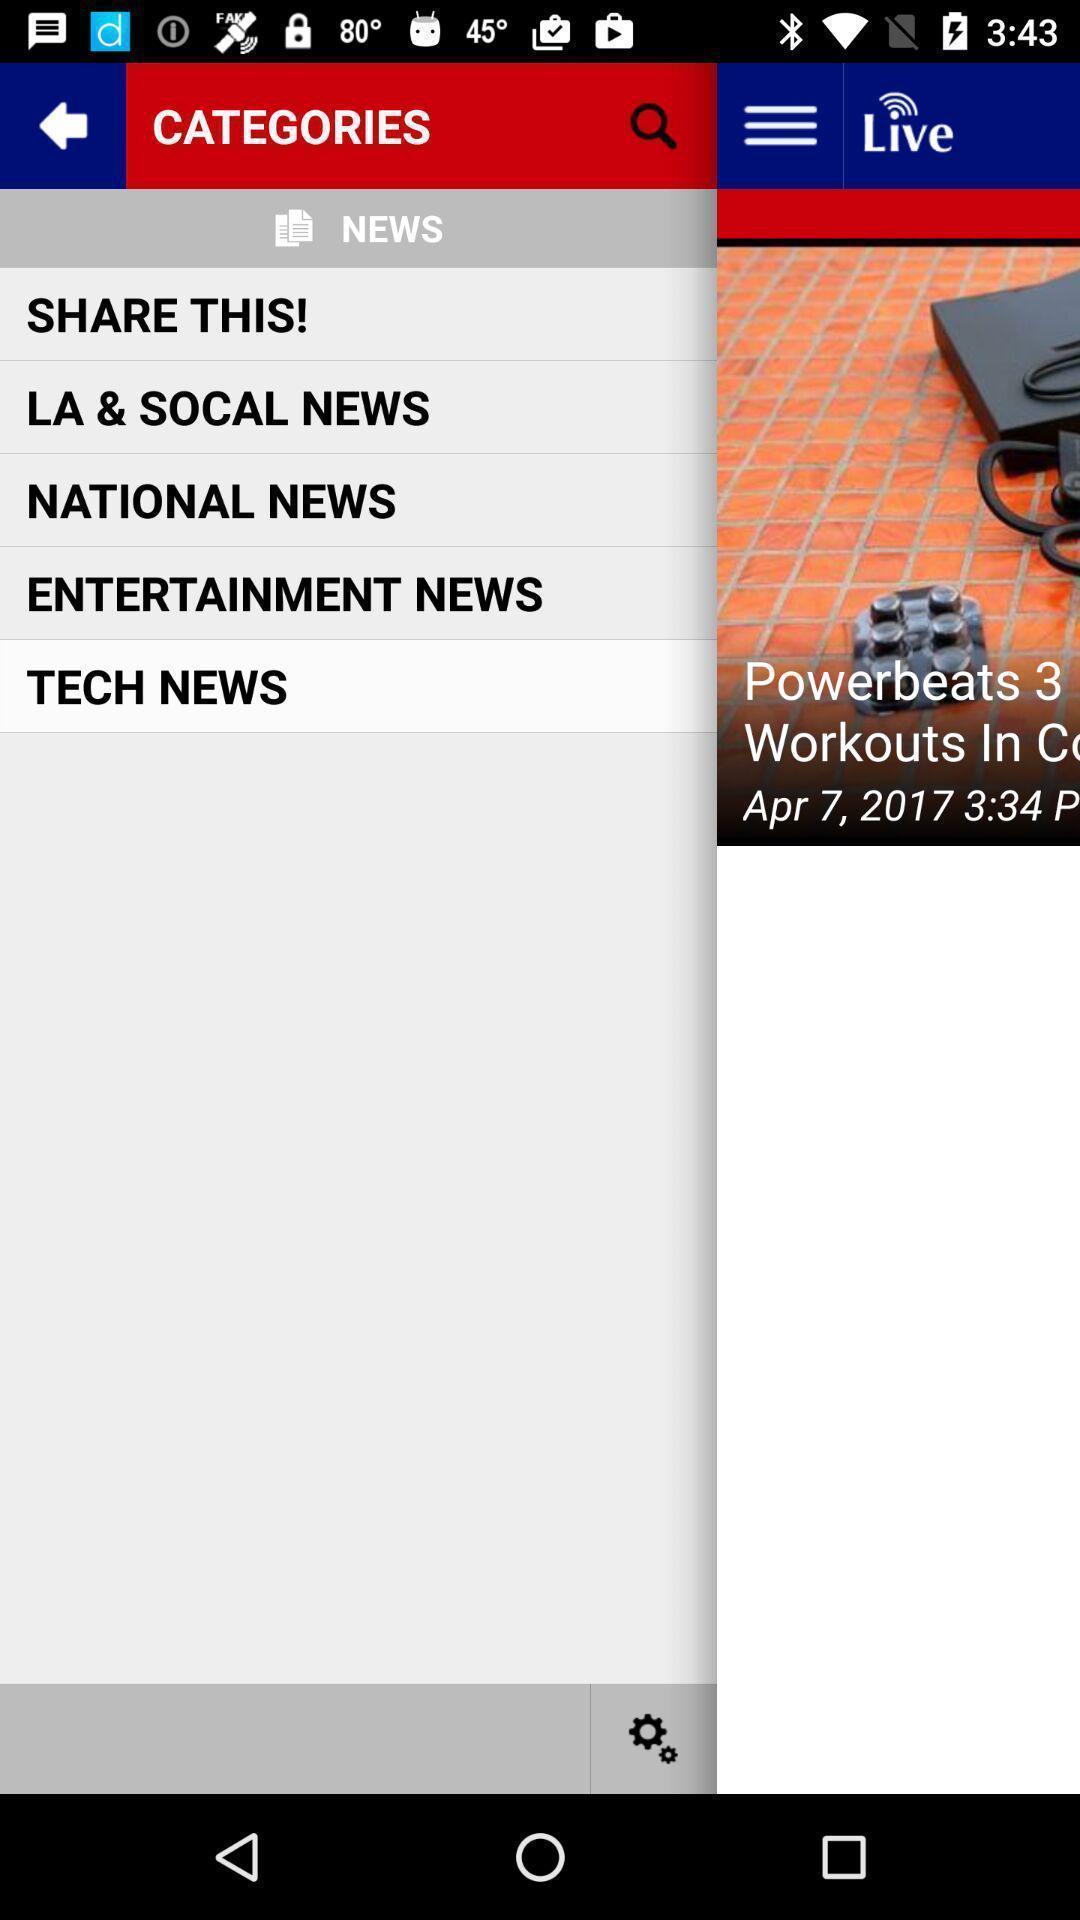What is the overall content of this screenshot? Page showing different categories. 